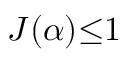<formula> <loc_0><loc_0><loc_500><loc_500>J ( \alpha ) { \leq } 1</formula> 